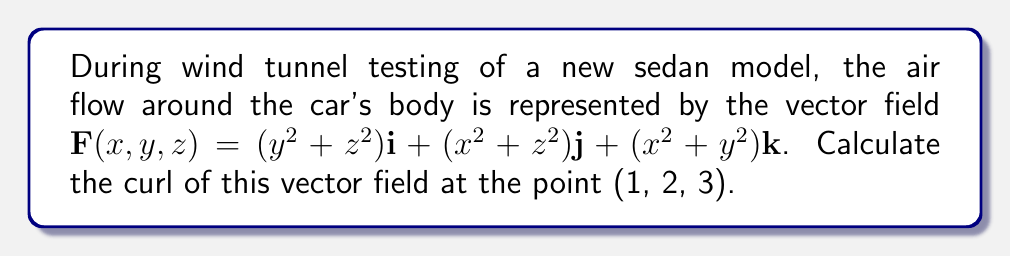Show me your answer to this math problem. To calculate the curl of the vector field, we need to follow these steps:

1. Recall the formula for curl in 3D:
   $$\text{curl }\mathbf{F} = \nabla \times \mathbf{F} = \left(\frac{\partial F_z}{\partial y} - \frac{\partial F_y}{\partial z}\right)\mathbf{i} + \left(\frac{\partial F_x}{\partial z} - \frac{\partial F_z}{\partial x}\right)\mathbf{j} + \left(\frac{\partial F_y}{\partial x} - \frac{\partial F_x}{\partial y}\right)\mathbf{k}$$

2. Identify the components of the vector field:
   $F_x = y^2+z^2$
   $F_y = x^2+z^2$
   $F_z = x^2+y^2$

3. Calculate the partial derivatives:
   $\frac{\partial F_z}{\partial y} = 2y$
   $\frac{\partial F_y}{\partial z} = 2z$
   $\frac{\partial F_x}{\partial z} = 2z$
   $\frac{\partial F_z}{\partial x} = 2x$
   $\frac{\partial F_y}{\partial x} = 2x$
   $\frac{\partial F_x}{\partial y} = 2y$

4. Substitute these derivatives into the curl formula:
   $$\text{curl }\mathbf{F} = (2y-2z)\mathbf{i} + (2z-2x)\mathbf{j} + (2x-2y)\mathbf{k}$$

5. Evaluate at the point (1, 2, 3):
   $$\text{curl }\mathbf{F}(1,2,3) = (2(2)-2(3))\mathbf{i} + (2(3)-2(1))\mathbf{j} + (2(1)-2(2))\mathbf{k}$$
   $$= (-2)\mathbf{i} + (4)\mathbf{j} + (-2)\mathbf{k}$$
Answer: $-2\mathbf{i} + 4\mathbf{j} - 2\mathbf{k}$ 